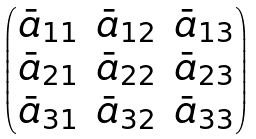<formula> <loc_0><loc_0><loc_500><loc_500>\begin{pmatrix} \bar { a } _ { 1 1 } & \bar { a } _ { 1 2 } & \bar { a } _ { 1 3 } \\ \bar { a } _ { 2 1 } & \bar { a } _ { 2 2 } & \bar { a } _ { 2 3 } \\ \bar { a } _ { 3 1 } & \bar { a } _ { 3 2 } & \bar { a } _ { 3 3 } \end{pmatrix}</formula> 